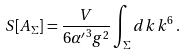<formula> <loc_0><loc_0><loc_500><loc_500>S [ A _ { \Sigma } ] = \frac { V } { 6 { \alpha ^ { \prime } } ^ { 3 } g ^ { 2 } } \int _ { \Sigma } d k \, k ^ { 6 } \, .</formula> 